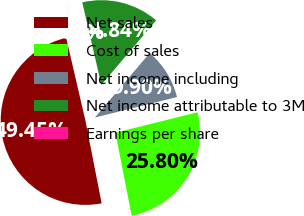Convert chart to OTSL. <chart><loc_0><loc_0><loc_500><loc_500><pie_chart><fcel>Net sales<fcel>Cost of sales<fcel>Net income including<fcel>Net income attributable to 3M<fcel>Earnings per share<nl><fcel>49.45%<fcel>25.8%<fcel>9.9%<fcel>14.84%<fcel>0.01%<nl></chart> 